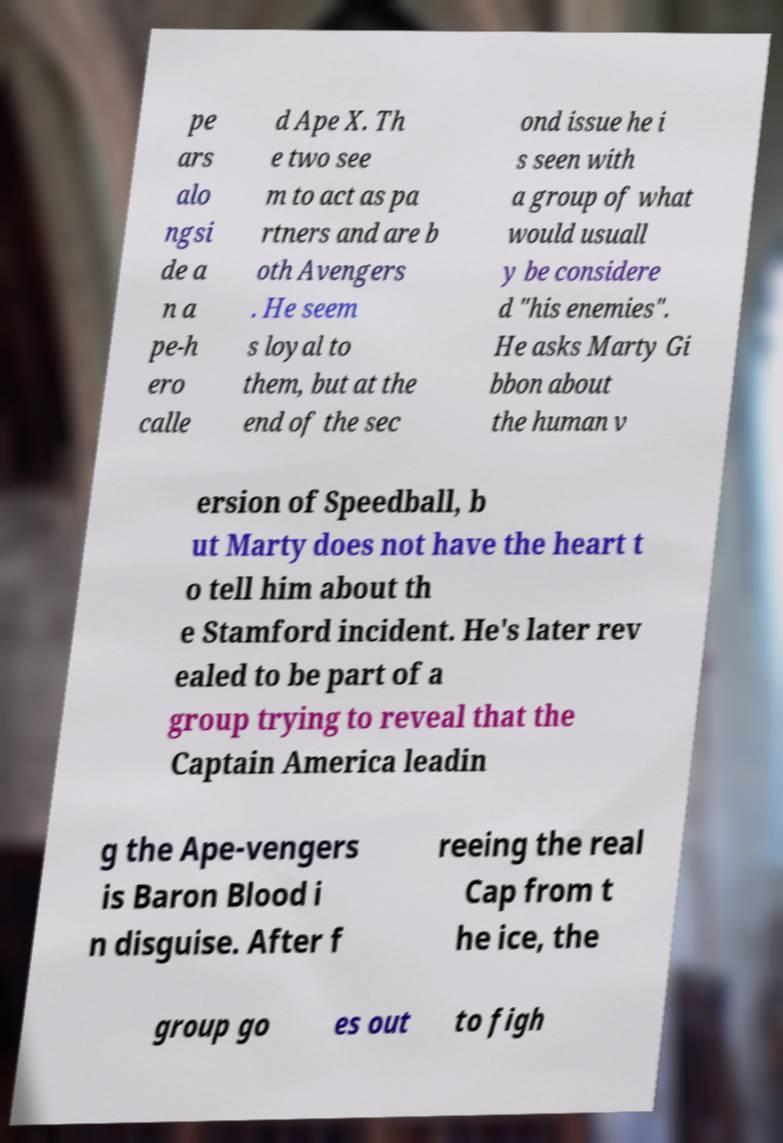Could you extract and type out the text from this image? pe ars alo ngsi de a n a pe-h ero calle d Ape X. Th e two see m to act as pa rtners and are b oth Avengers . He seem s loyal to them, but at the end of the sec ond issue he i s seen with a group of what would usuall y be considere d "his enemies". He asks Marty Gi bbon about the human v ersion of Speedball, b ut Marty does not have the heart t o tell him about th e Stamford incident. He's later rev ealed to be part of a group trying to reveal that the Captain America leadin g the Ape-vengers is Baron Blood i n disguise. After f reeing the real Cap from t he ice, the group go es out to figh 